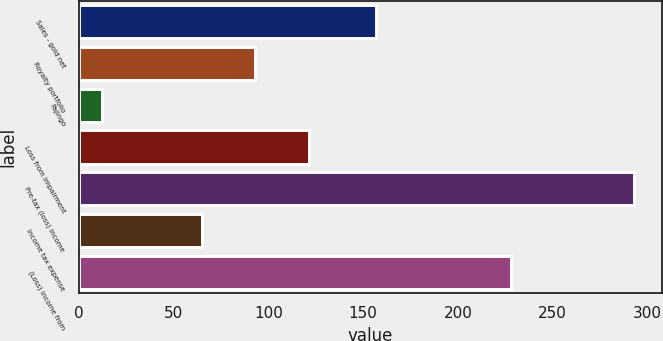<chart> <loc_0><loc_0><loc_500><loc_500><bar_chart><fcel>Sales - gold net<fcel>Royalty portfolio<fcel>Pajingo<fcel>Loss from impairment<fcel>Pre-tax (loss) income<fcel>Income tax expense<fcel>(Loss) income from<nl><fcel>157<fcel>93.1<fcel>12<fcel>121.2<fcel>293<fcel>65<fcel>228<nl></chart> 